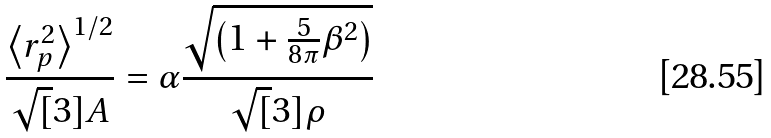<formula> <loc_0><loc_0><loc_500><loc_500>\frac { \left \langle r _ { p } ^ { 2 } \right \rangle ^ { 1 / 2 } } { \sqrt { [ } 3 ] { A } } = \alpha \frac { \sqrt { \left ( 1 + \frac { 5 } { 8 \pi } \beta ^ { 2 } \right ) } } { \sqrt { [ } 3 ] { \rho } }</formula> 